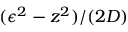Convert formula to latex. <formula><loc_0><loc_0><loc_500><loc_500>( \epsilon ^ { 2 } - z ^ { 2 } ) / ( 2 D )</formula> 